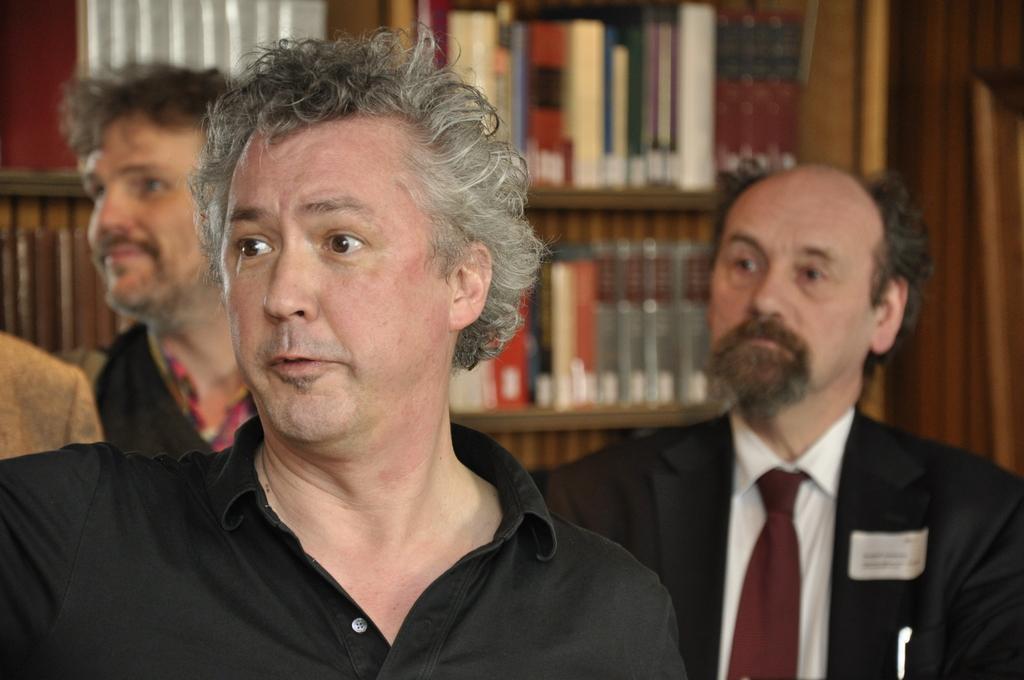How would you summarize this image in a sentence or two? At the left corner of the image there is a man with black t-shirt. Behind him there is a person. At the right side of the image there is a man with black jacket, white shirt and maroon tie. In the background there is a cupboard with many books in it. 